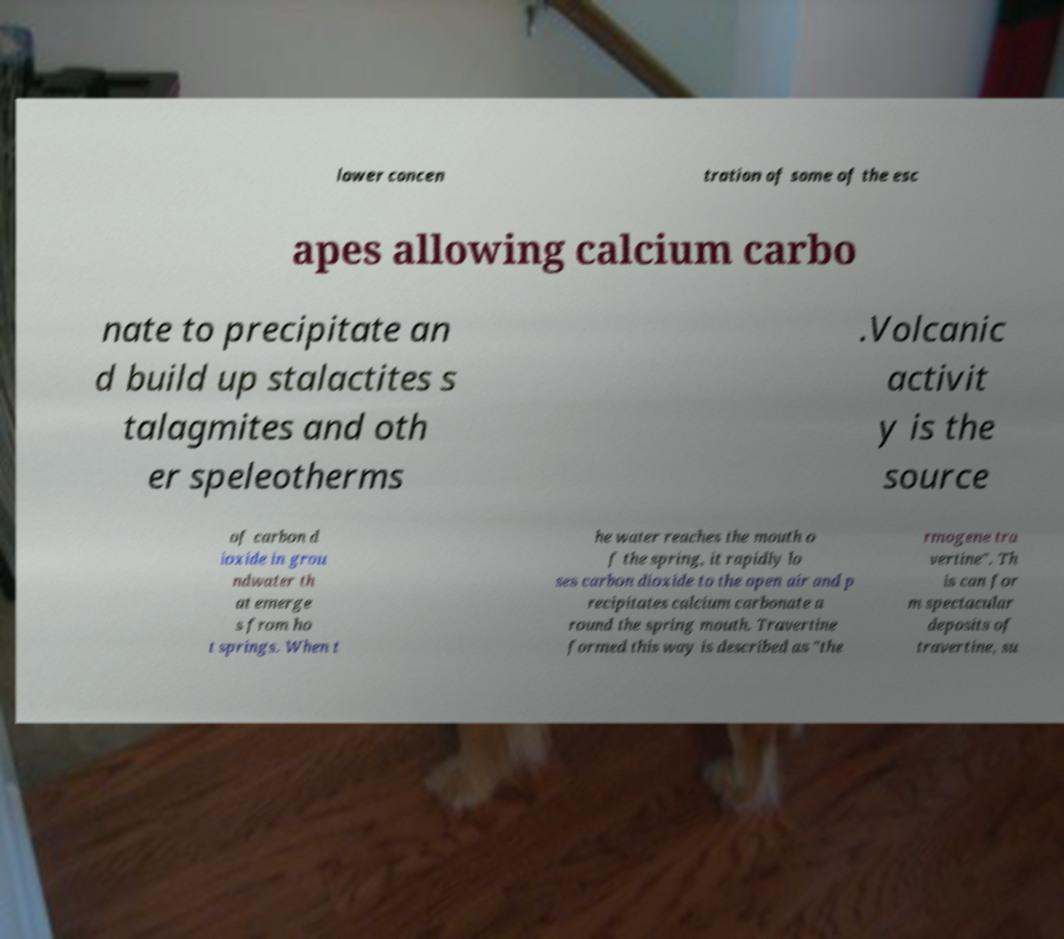For documentation purposes, I need the text within this image transcribed. Could you provide that? lower concen tration of some of the esc apes allowing calcium carbo nate to precipitate an d build up stalactites s talagmites and oth er speleotherms .Volcanic activit y is the source of carbon d ioxide in grou ndwater th at emerge s from ho t springs. When t he water reaches the mouth o f the spring, it rapidly lo ses carbon dioxide to the open air and p recipitates calcium carbonate a round the spring mouth. Travertine formed this way is described as "the rmogene tra vertine". Th is can for m spectacular deposits of travertine, su 